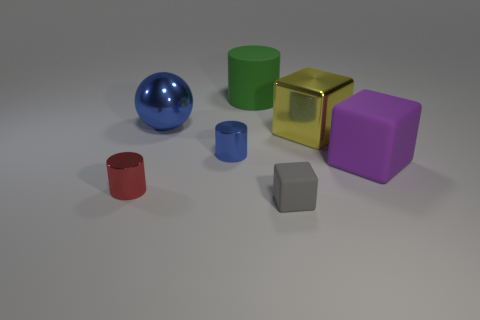Subtract all metallic cylinders. How many cylinders are left? 1 Add 3 red shiny cylinders. How many objects exist? 10 Subtract all blocks. How many objects are left? 4 Subtract all blue metal cylinders. Subtract all tiny blue objects. How many objects are left? 5 Add 1 small gray rubber things. How many small gray rubber things are left? 2 Add 1 large blue rubber cylinders. How many large blue rubber cylinders exist? 1 Subtract 0 gray spheres. How many objects are left? 7 